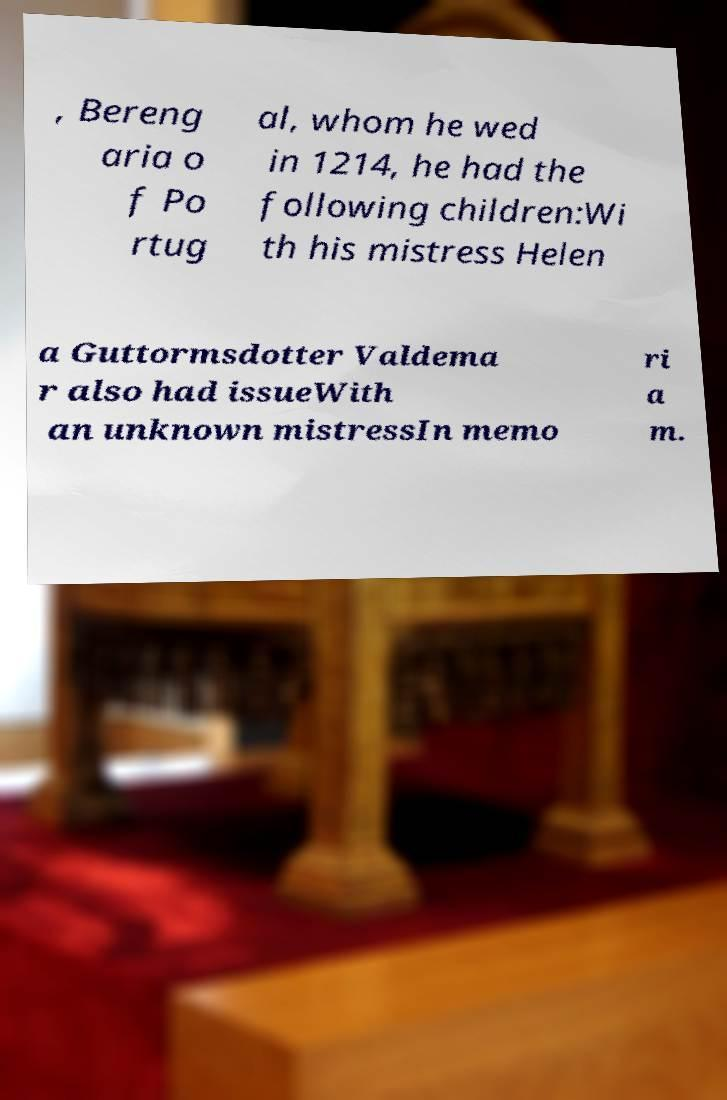Could you extract and type out the text from this image? , Bereng aria o f Po rtug al, whom he wed in 1214, he had the following children:Wi th his mistress Helen a Guttormsdotter Valdema r also had issueWith an unknown mistressIn memo ri a m. 